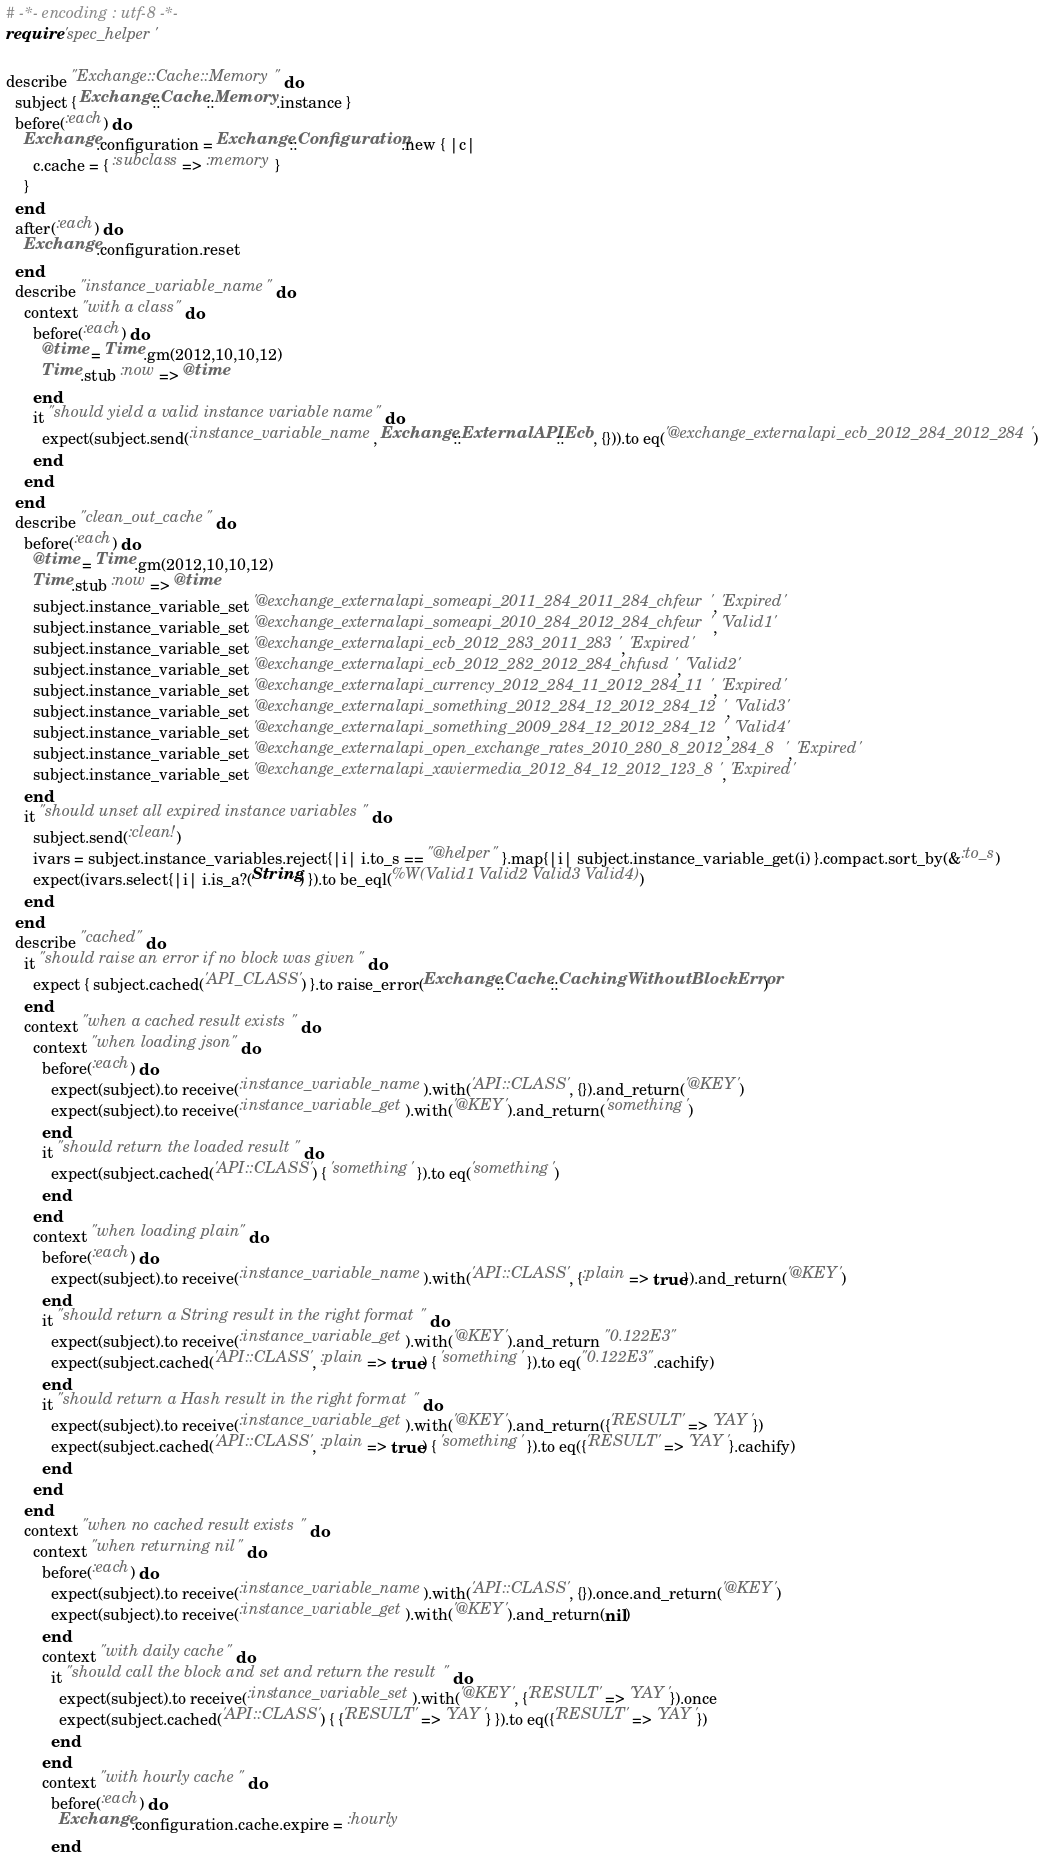Convert code to text. <code><loc_0><loc_0><loc_500><loc_500><_Ruby_># -*- encoding : utf-8 -*-
require 'spec_helper'

describe "Exchange::Cache::Memory" do
  subject { Exchange::Cache::Memory.instance }
  before(:each) do
    Exchange.configuration = Exchange::Configuration.new { |c|
      c.cache = { :subclass => :memory }
    }
  end
  after(:each) do
    Exchange.configuration.reset
  end
  describe "instance_variable_name" do
    context "with a class" do
      before(:each) do
        @time = Time.gm(2012,10,10,12)
        Time.stub :now => @time
      end
      it "should yield a valid instance variable name" do
        expect(subject.send(:instance_variable_name, Exchange::ExternalAPI::Ecb, {})).to eq('@exchange_externalapi_ecb_2012_284_2012_284')
      end
    end
  end
  describe "clean_out_cache" do
    before(:each) do
      @time = Time.gm(2012,10,10,12)
      Time.stub :now => @time
      subject.instance_variable_set '@exchange_externalapi_someapi_2011_284_2011_284_chfeur', 'Expired'
      subject.instance_variable_set '@exchange_externalapi_someapi_2010_284_2012_284_chfeur', 'Valid1'
      subject.instance_variable_set '@exchange_externalapi_ecb_2012_283_2011_283', 'Expired'
      subject.instance_variable_set '@exchange_externalapi_ecb_2012_282_2012_284_chfusd', 'Valid2'
      subject.instance_variable_set '@exchange_externalapi_currency_2012_284_11_2012_284_11', 'Expired'
      subject.instance_variable_set '@exchange_externalapi_something_2012_284_12_2012_284_12', 'Valid3'
      subject.instance_variable_set '@exchange_externalapi_something_2009_284_12_2012_284_12', 'Valid4'
      subject.instance_variable_set '@exchange_externalapi_open_exchange_rates_2010_280_8_2012_284_8', 'Expired'
      subject.instance_variable_set '@exchange_externalapi_xaviermedia_2012_84_12_2012_123_8', 'Expired'
    end
    it "should unset all expired instance variables" do
      subject.send(:clean!)
      ivars = subject.instance_variables.reject{|i| i.to_s == "@helper" }.map{|i| subject.instance_variable_get(i) }.compact.sort_by(&:to_s)
      expect(ivars.select{|i| i.is_a?(String) }).to be_eql(%W(Valid1 Valid2 Valid3 Valid4))
    end
  end
  describe "cached" do
    it "should raise an error if no block was given" do
      expect { subject.cached('API_CLASS') }.to raise_error(Exchange::Cache::CachingWithoutBlockError)
    end
    context "when a cached result exists" do
      context "when loading json" do
        before(:each) do
          expect(subject).to receive(:instance_variable_name).with('API::CLASS', {}).and_return('@KEY')
          expect(subject).to receive(:instance_variable_get).with('@KEY').and_return('something')
        end
        it "should return the loaded result" do
          expect(subject.cached('API::CLASS') { 'something' }).to eq('something')
        end
      end
      context "when loading plain" do
        before(:each) do
          expect(subject).to receive(:instance_variable_name).with('API::CLASS', {:plain => true}).and_return('@KEY')
        end
        it "should return a String result in the right format" do
          expect(subject).to receive(:instance_variable_get).with('@KEY').and_return "0.122E3"
          expect(subject.cached('API::CLASS', :plain => true) { 'something' }).to eq("0.122E3".cachify)
        end
        it "should return a Hash result in the right format" do
          expect(subject).to receive(:instance_variable_get).with('@KEY').and_return({'RESULT' => 'YAY'})
          expect(subject.cached('API::CLASS', :plain => true) { 'something' }).to eq({'RESULT' => 'YAY'}.cachify)
        end
      end
    end
    context "when no cached result exists" do
      context "when returning nil" do
        before(:each) do
          expect(subject).to receive(:instance_variable_name).with('API::CLASS', {}).once.and_return('@KEY')
          expect(subject).to receive(:instance_variable_get).with('@KEY').and_return(nil)
        end
        context "with daily cache" do
          it "should call the block and set and return the result" do
            expect(subject).to receive(:instance_variable_set).with('@KEY', {'RESULT' => 'YAY'}).once
            expect(subject.cached('API::CLASS') { {'RESULT' => 'YAY'} }).to eq({'RESULT' => 'YAY'})
          end
        end
        context "with hourly cache" do
          before(:each) do
            Exchange.configuration.cache.expire = :hourly
          end</code> 